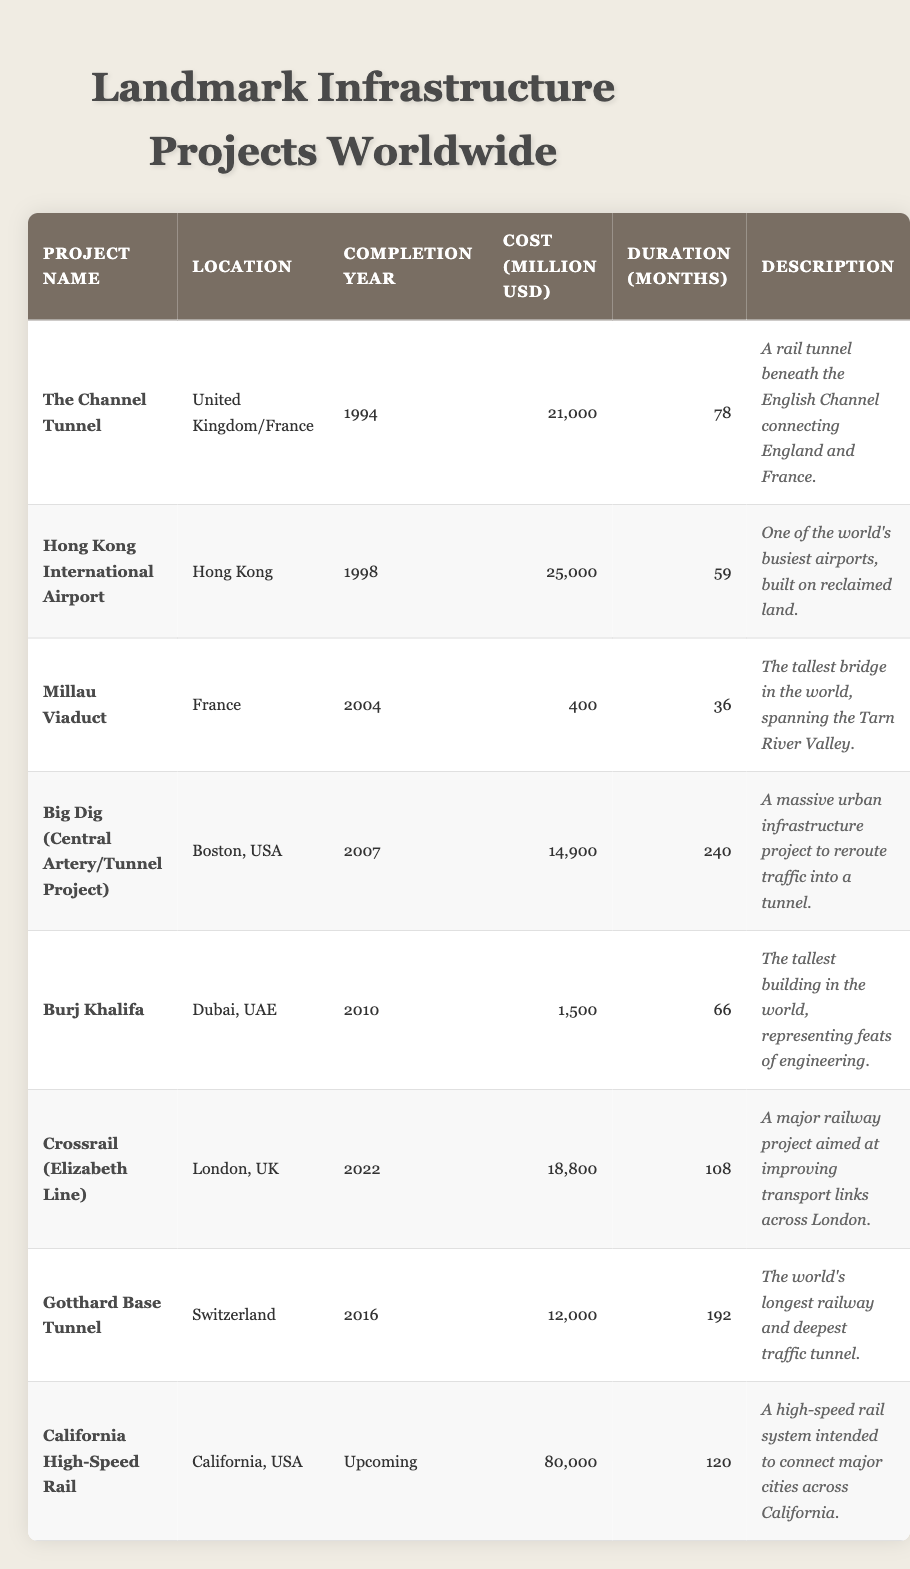What is the total cost of the infrastructure projects listed? To find the total cost, sum the individual project costs from the table: 21,000 + 25,000 + 400 + 14,900 + 1,500 + 18,800 + 12,000 + 80,000 = 173,600 million USD.
Answer: 173,600 million USD Which project had the longest duration? The longest duration is 240 months, which corresponds to the Big Dig (Central Artery/Tunnel Project).
Answer: The Big Dig What year was the Millau Viaduct completed? The completion year for the Millau Viaduct is directly listed in the table as 2004.
Answer: 2004 Is the California High-Speed Rail project completed? According to the table, it is listed as "Upcoming," indicating it has not yet been completed.
Answer: No What percentage of the total cost do the Burj Khalifa's costs represent? First, the cost of the Burj Khalifa is 1,500 million USD. The total cost is 173,600 million USD. The percentage is (1,500 / 173,600) * 100 ≈ 0.86%.
Answer: Approximately 0.86% How many months did the Hong Kong International Airport take to complete? The duration for the Hong Kong International Airport project is clearly listed as 59 months in the table.
Answer: 59 months Which two projects have costs under 1 billion USD? Reviewing the costs, both the Millau Viaduct (400 million USD) and Burj Khalifa (1,500 million USD) are below 1 billion. The criteria only allow for those below 1 billion, leading to the conclusion that only Millau Viaduct meets the requirement.
Answer: The Millau Viaduct Which location has the highest project cost listed? Looking at the costs, the California High-Speed Rail has the highest listed project cost at 80,000 million USD. Comparative values of other projects support this conclusion as none exceed this value.
Answer: California High-Speed Rail How many years did the Gotthard Base Tunnel take to complete? The Gotthard Base Tunnel took 192 months to complete. To convert months to years, divide by 12: 192 / 12 = 16 years.
Answer: 16 years What is the average duration of all projects listed? To find the average duration, add up all the durations: 78 + 59 + 36 + 240 + 66 + 108 + 192 + 120 = 899 months. Then divide by the number of projects (8): 899 / 8 = 112.375 months.
Answer: Approximately 112.38 months 